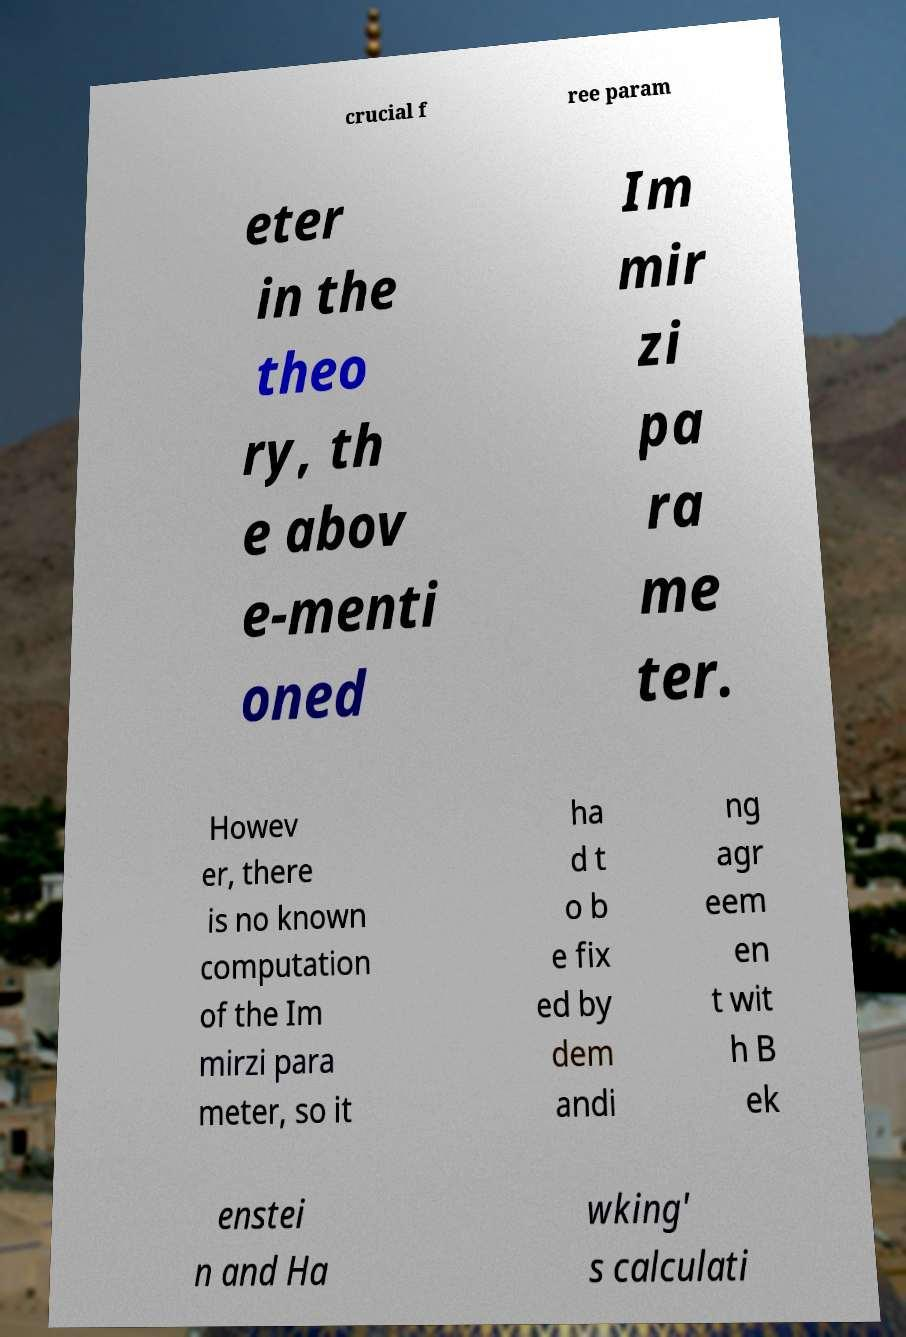I need the written content from this picture converted into text. Can you do that? crucial f ree param eter in the theo ry, th e abov e-menti oned Im mir zi pa ra me ter. Howev er, there is no known computation of the Im mirzi para meter, so it ha d t o b e fix ed by dem andi ng agr eem en t wit h B ek enstei n and Ha wking' s calculati 